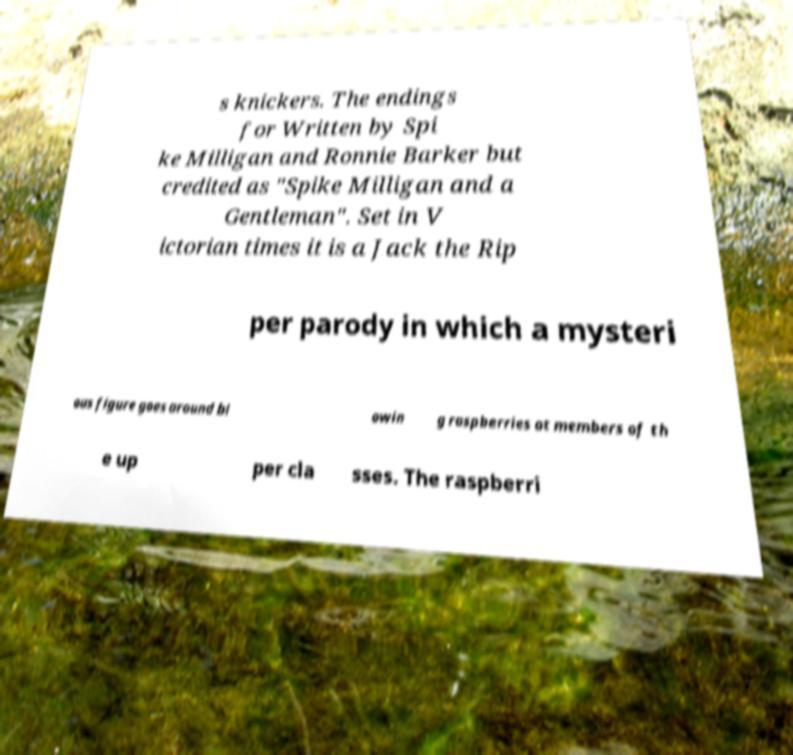What messages or text are displayed in this image? I need them in a readable, typed format. s knickers. The endings for Written by Spi ke Milligan and Ronnie Barker but credited as "Spike Milligan and a Gentleman". Set in V ictorian times it is a Jack the Rip per parody in which a mysteri ous figure goes around bl owin g raspberries at members of th e up per cla sses. The raspberri 